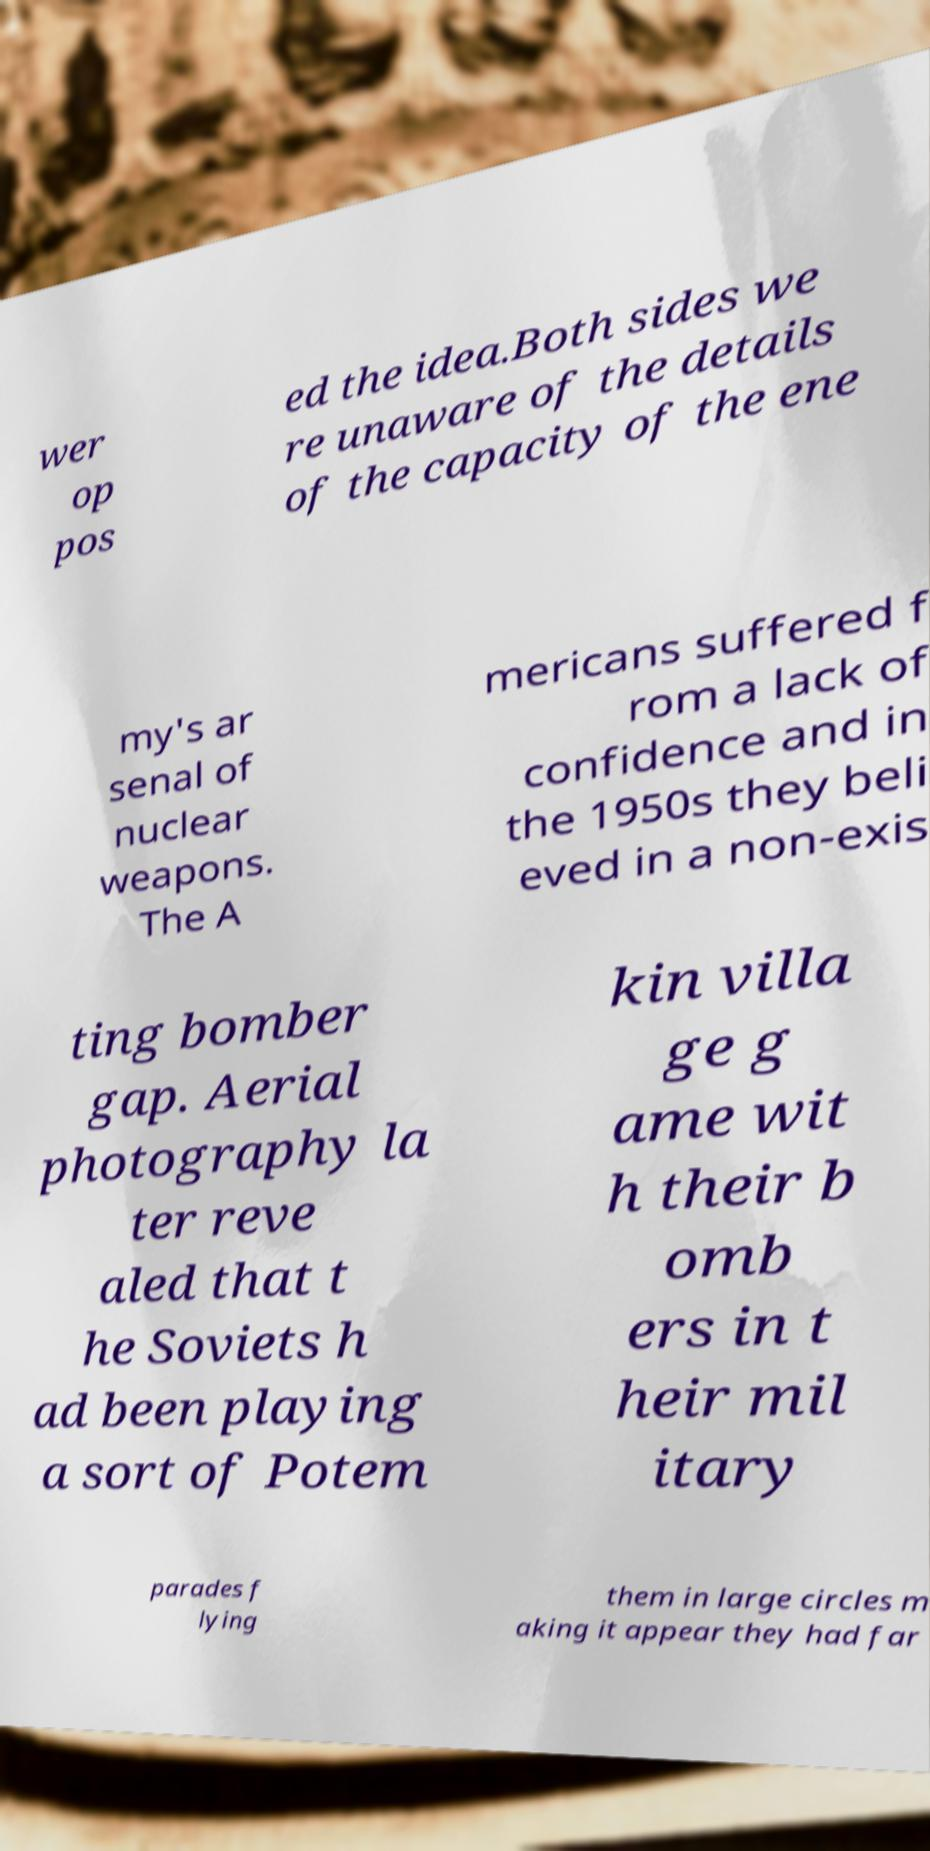Can you read and provide the text displayed in the image?This photo seems to have some interesting text. Can you extract and type it out for me? wer op pos ed the idea.Both sides we re unaware of the details of the capacity of the ene my's ar senal of nuclear weapons. The A mericans suffered f rom a lack of confidence and in the 1950s they beli eved in a non-exis ting bomber gap. Aerial photography la ter reve aled that t he Soviets h ad been playing a sort of Potem kin villa ge g ame wit h their b omb ers in t heir mil itary parades f lying them in large circles m aking it appear they had far 